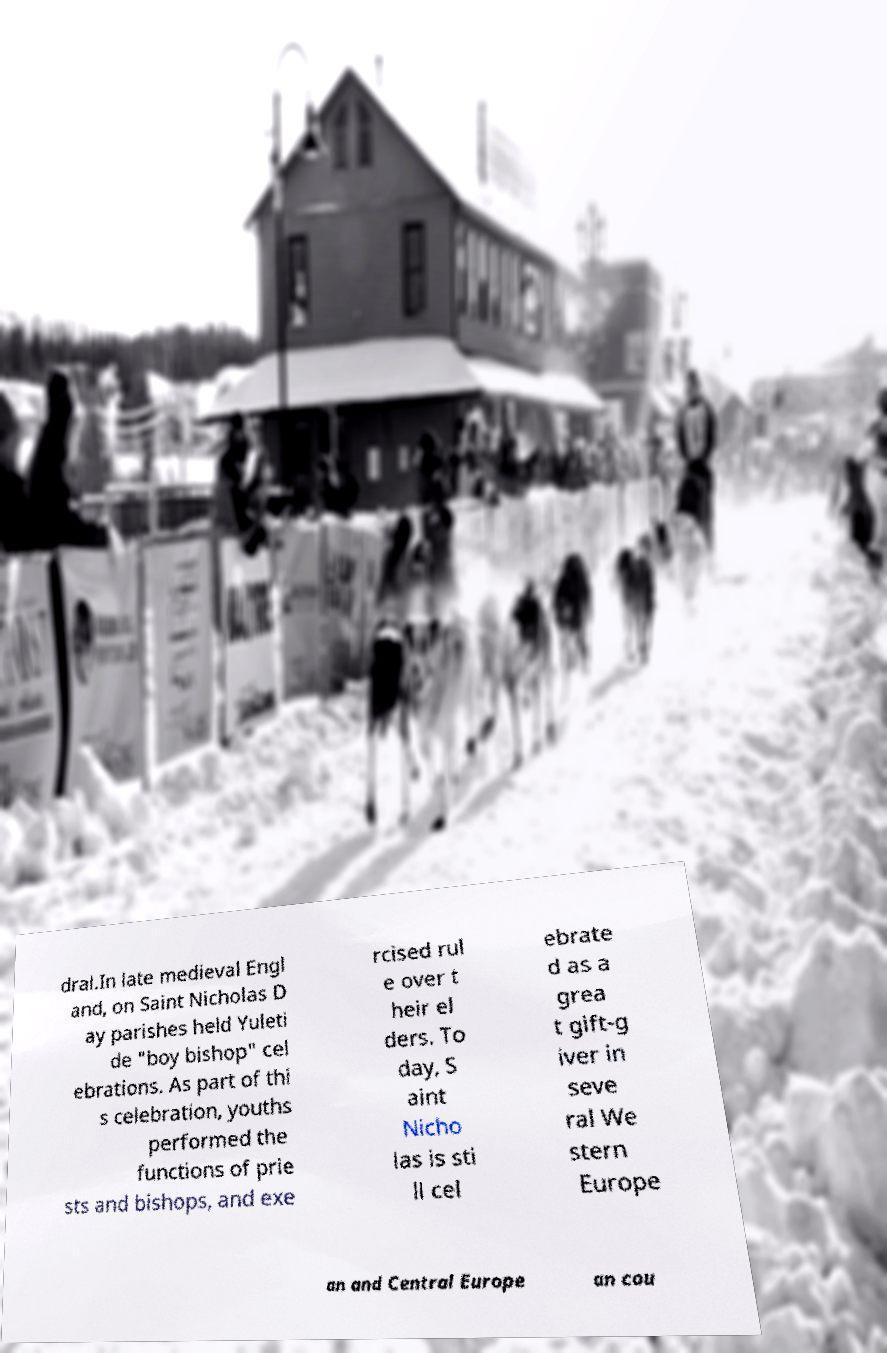Could you extract and type out the text from this image? dral.In late medieval Engl and, on Saint Nicholas D ay parishes held Yuleti de "boy bishop" cel ebrations. As part of thi s celebration, youths performed the functions of prie sts and bishops, and exe rcised rul e over t heir el ders. To day, S aint Nicho las is sti ll cel ebrate d as a grea t gift-g iver in seve ral We stern Europe an and Central Europe an cou 